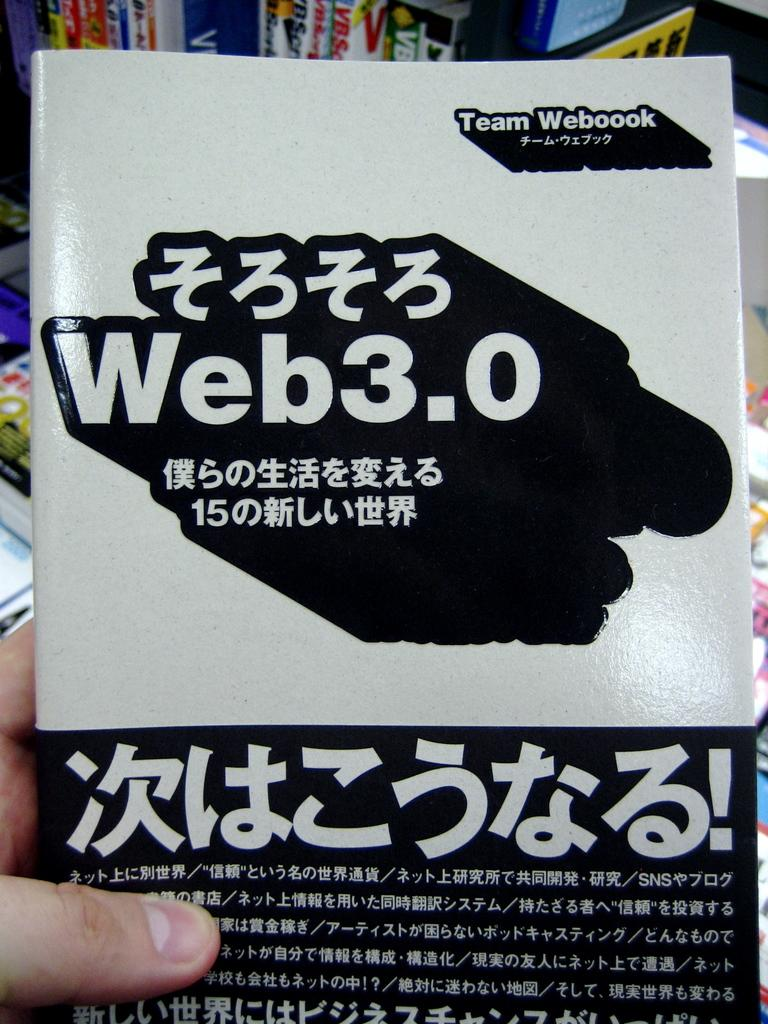<image>
Describe the image concisely. a japanese language web 3.0 instruction booklet by team webbook. 